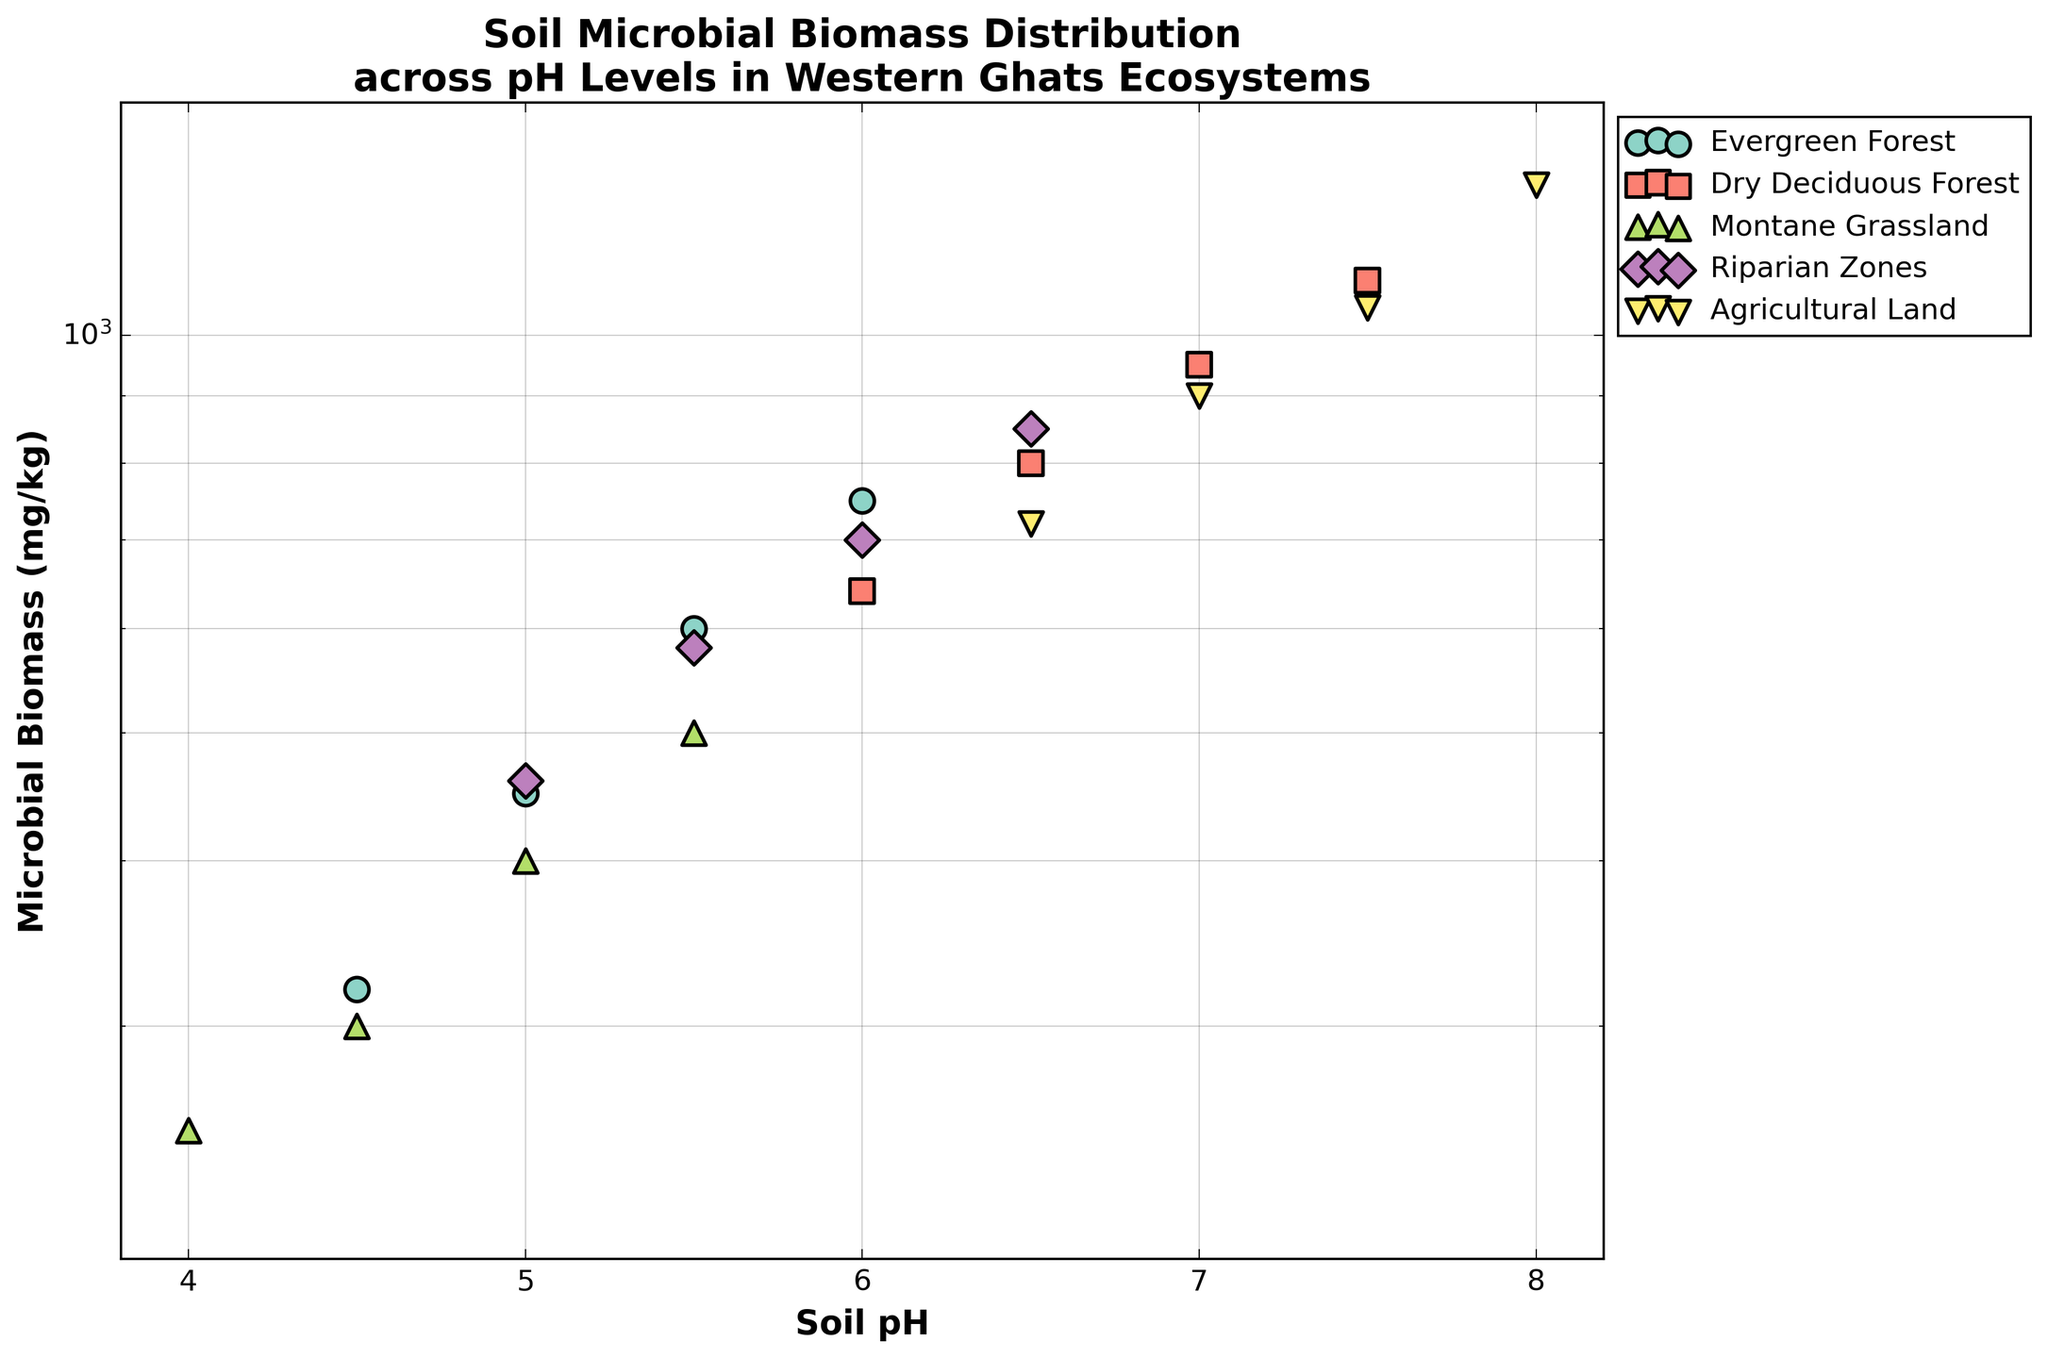What is the title of the figure? The title is located at the top of the figure and summarizes what the figure is about. According to the plot generation code, the title is: "Soil Microbial Biomass Distribution across pH Levels in Western Ghats Ecosystems"
Answer: Soil Microbial Biomass Distribution across pH Levels in Western Ghats Ecosystems Which ecosystem has the highest microbial biomass at a soil pH level of 4.5? By examining the scatter plots, we can compare all the ecosystems at a soil pH level of 4.5. The highest microbial biomass value at this pH is observed in the Evergreen Forest, which is 320 mg/kg.
Answer: Evergreen Forest How does the microbial biomass in Dry Deciduous Forests change as soil pH increases from 6.0 to 7.5? To address this, we look at the data points for Dry Deciduous Forests at pH 6.0, 6.5, 7.0, and 7.5. The microbial biomass values are 640, 800, 950, and 1100 mg/kg, respectively. This shows an increasing trend with rising soil pH.
Answer: It increases What range do the soil pH levels cover in this figure? Examining the x-axis of the figure, the soil pH levels range from the minimum to the maximum value shown. From the plot code and the figure, the x-axis limits are set between 3.8 and 8.2.
Answer: 3.8 to 8.2 Which ecosystem shows the lowest microbial biomass, and at what soil pH level does this occur? To find this, we need to identify the lowest microbial biomass value across all ecosystems and the corresponding soil pH level. The lowest value is 250 mg/kg in the Montane Grassland at a soil pH of 4.0.
Answer: Montane Grassland at 4.0 pH Between which two ecosystems is there the largest difference in microbial biomass at a soil pH of 6.5? For soil pH 6.5, compare the microbial biomass values of all ecosystems. The values are 850 for Riparian Zones, 800 for Dry Deciduous Forest, and 720 for Agricultural Land. The largest difference is between Riparian Zones and Agricultural Land (850 - 720 = 130 mg/kg).
Answer: Riparian Zones and Agricultural Land Which ecosystem has the highest microbial biomass, and what is the corresponding soil pH level? By examining the maximum value on the y-axis and identifying the corresponding ecosystem, we see that Agricultural Land has the highest microbial biomass at a soil pH of 8.0. The value is 1300 mg/kg.
Answer: Agricultural Land at 8.0 pH What is the general trend of microbial biomass in Evergreen Forests as the soil pH increases from 4.5 to 6.0? By observing the data points for Evergreen Forests, we find that the microbial biomass values at pH 4.5, 5.0, 5.5, and 6.0 are 320, 450, 600, and 750 mg/kg, respectively. This indicates an increasing trend with increasing soil pH.
Answer: It increases What does the y-axis represent, and in what measurement unit? The y-axis label indicates that it represents microbial biomass. The unit of measurement is mg/kg (milligrams per kilogram), as inferred from the label “Microbial Biomass (mg/kg)”.
Answer: Microbial biomass in mg/kg 